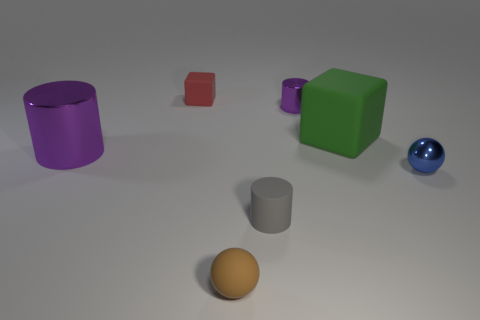Which objects seem to have a metallic finish? The objects with a shiny metallic finish are the blue sphere and the silver cylinder. They reflect the light and exhibit highlights consistent with metallic surfaces. And which object looks the most reflective? The blue sphere is the most reflective object in the image, showcasing clear specular highlights and distinct reflections of the environment. 